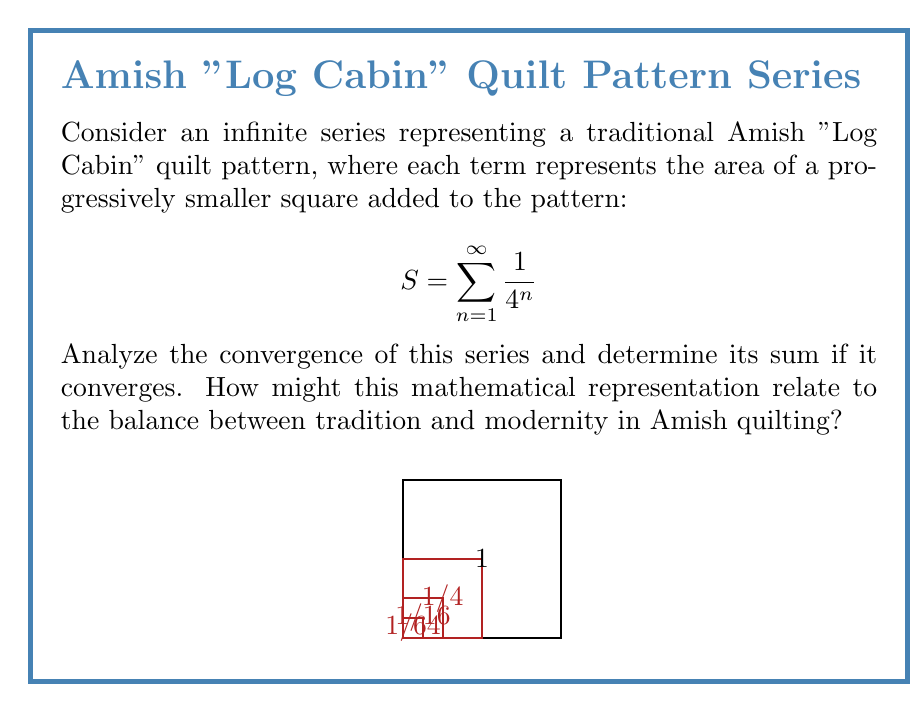Teach me how to tackle this problem. To analyze the convergence of this series, we'll use the concept of geometric series and the ratio test.

1) First, recognize that this is a geometric series with first term $a=\frac{1}{4}$ and common ratio $r=\frac{1}{4}$.

2) For a geometric series $\sum_{n=1}^{\infty} ar^{n-1}$, it converges if $|r| < 1$.

3) In this case, $|r| = |\frac{1}{4}| = \frac{1}{4} < 1$, so the series converges.

4) For a convergent geometric series, the sum is given by the formula:
   $$S = \frac{a}{1-r} = \frac{\frac{1}{4}}{1-\frac{1}{4}} = \frac{\frac{1}{4}}{\frac{3}{4}} = \frac{1}{3}$$

5) We can also verify this using the ratio test:
   $$\lim_{n\to\infty} |\frac{a_{n+1}}{a_n}| = \lim_{n\to\infty} |\frac{\frac{1}{4^{n+1}}}{\frac{1}{4^n}}| = \lim_{n\to\infty} \frac{1}{4} = \frac{1}{4} < 1$$

   This confirms the series converges.

6) Interpretation: The sum $\frac{1}{3}$ represents the total area covered by all squares in the infinite pattern. Each term represents a smaller square, symbolizing how traditional patterns can be infinitely refined and adapted, potentially representing a balance between tradition (the overall pattern) and modernity (the infinite progression and mathematical representation).
Answer: The series converges to $\frac{1}{3}$. 